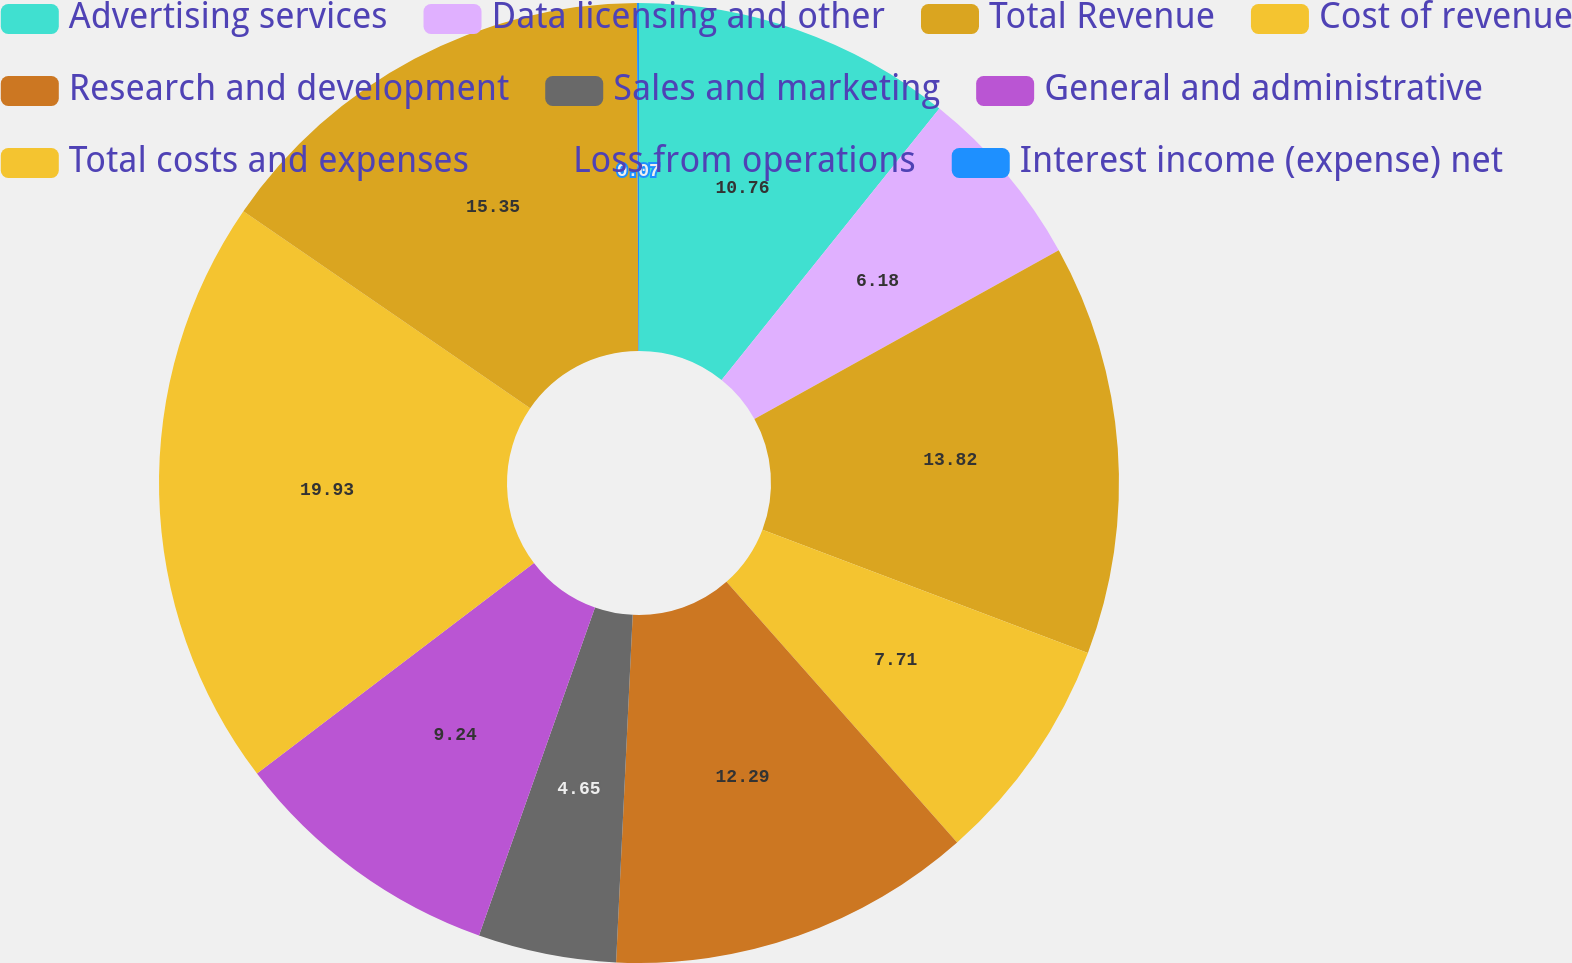Convert chart. <chart><loc_0><loc_0><loc_500><loc_500><pie_chart><fcel>Advertising services<fcel>Data licensing and other<fcel>Total Revenue<fcel>Cost of revenue<fcel>Research and development<fcel>Sales and marketing<fcel>General and administrative<fcel>Total costs and expenses<fcel>Loss from operations<fcel>Interest income (expense) net<nl><fcel>10.76%<fcel>6.18%<fcel>13.82%<fcel>7.71%<fcel>12.29%<fcel>4.65%<fcel>9.24%<fcel>19.93%<fcel>15.35%<fcel>0.07%<nl></chart> 